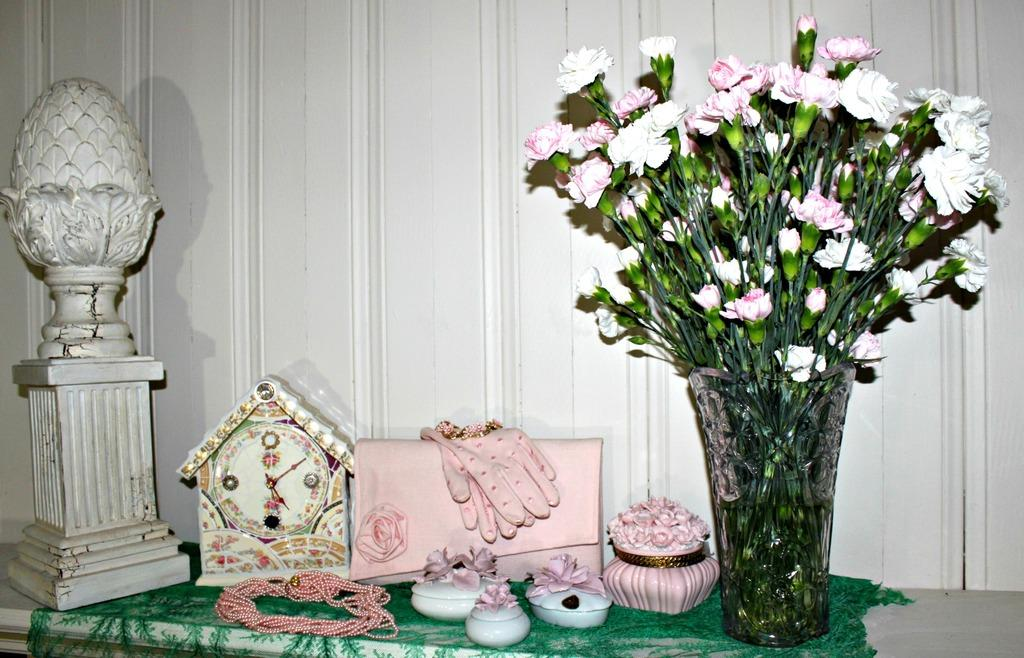What object is located on the right side of the image? There is a flower vase on the right side of the image. What else can be seen in the image besides the flower vase? There is a watch and gloves in the image. What type of lip can be seen on the watch in the image? There is no lip present on the watch in the image. What kind of blade is being used to cut the gloves in the image? There is no blade or cutting action depicted in the image; the gloves are simply present. 